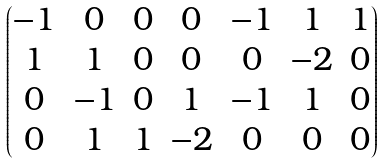<formula> <loc_0><loc_0><loc_500><loc_500>\begin{pmatrix} - 1 & 0 & 0 & 0 & - 1 & 1 & 1 \\ 1 & 1 & 0 & 0 & 0 & - 2 & 0 \\ 0 & - 1 & 0 & 1 & - 1 & 1 & 0 \\ 0 & 1 & 1 & - 2 & 0 & 0 & 0 \end{pmatrix}</formula> 